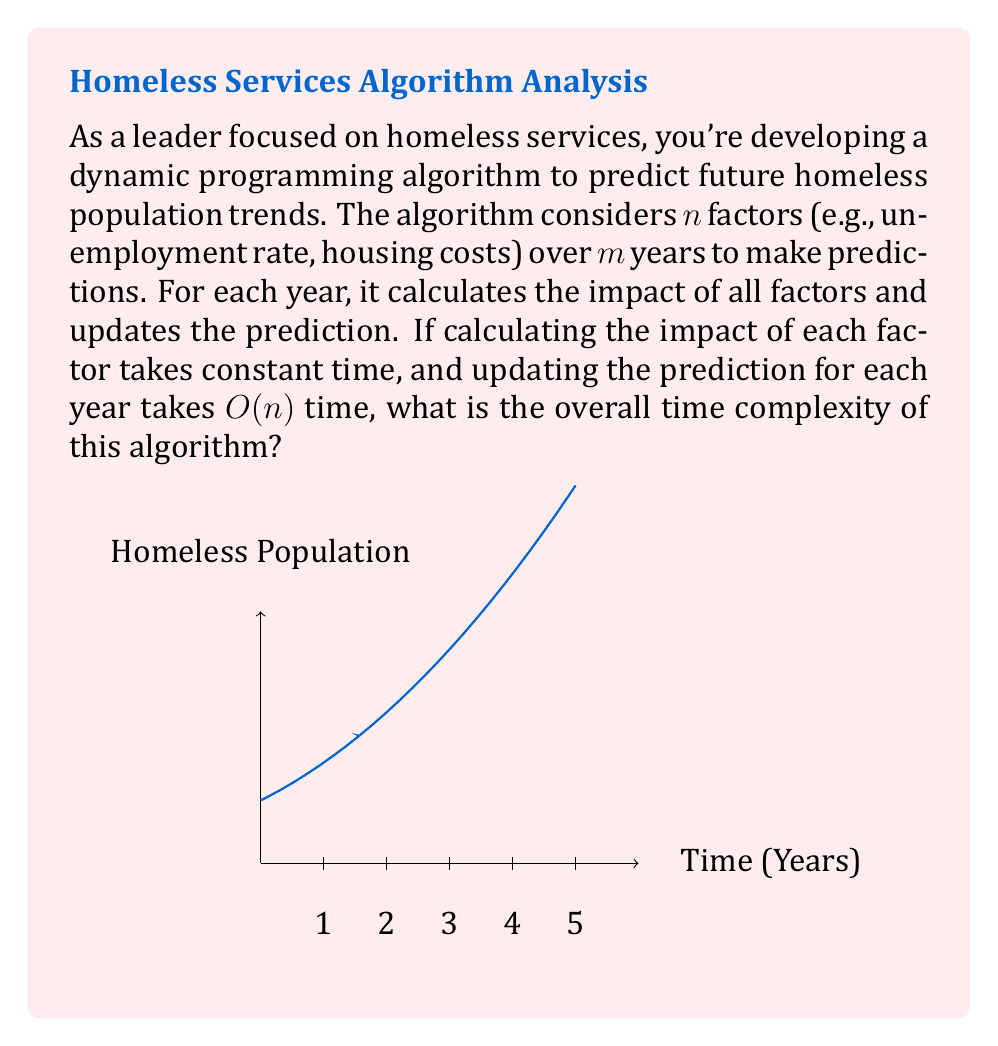What is the answer to this math problem? Let's analyze the algorithm step-by-step:

1) For each year, we need to:
   a) Calculate the impact of all $n$ factors
   b) Update the prediction based on these factors

2) Calculating the impact of each factor takes constant time, so for $n$ factors:
   $$ \text{Time for impact calculation} = O(n) $$

3) Updating the prediction takes $O(n)$ time for each year.

4) We perform these operations for $m$ years, so we multiply the time by $m$:
   $$ \text{Total time} = m \cdot (O(n) + O(n)) = m \cdot O(n) $$

5) Simplifying:
   $$ \text{Time complexity} = O(mn) $$

This quadratic time complexity arises because for each of the $m$ years, we're performing operations that depend on all $n$ factors.
Answer: $O(mn)$ 